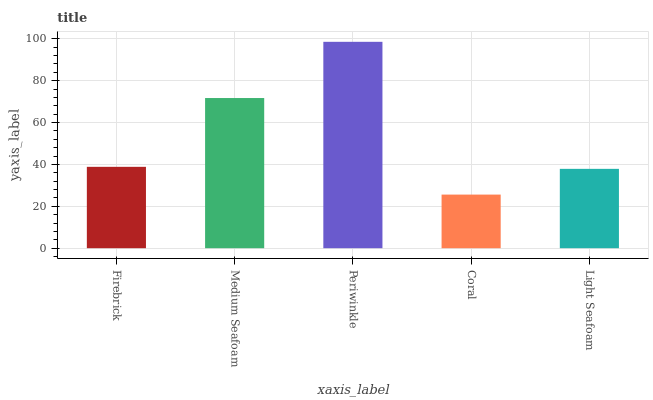Is Coral the minimum?
Answer yes or no. Yes. Is Periwinkle the maximum?
Answer yes or no. Yes. Is Medium Seafoam the minimum?
Answer yes or no. No. Is Medium Seafoam the maximum?
Answer yes or no. No. Is Medium Seafoam greater than Firebrick?
Answer yes or no. Yes. Is Firebrick less than Medium Seafoam?
Answer yes or no. Yes. Is Firebrick greater than Medium Seafoam?
Answer yes or no. No. Is Medium Seafoam less than Firebrick?
Answer yes or no. No. Is Firebrick the high median?
Answer yes or no. Yes. Is Firebrick the low median?
Answer yes or no. Yes. Is Periwinkle the high median?
Answer yes or no. No. Is Light Seafoam the low median?
Answer yes or no. No. 